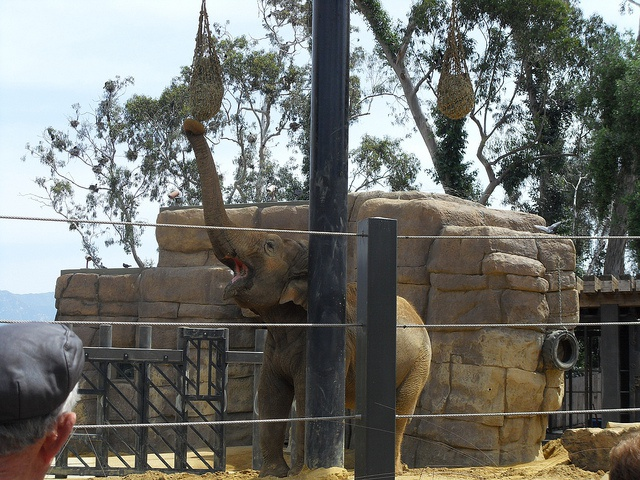Describe the objects in this image and their specific colors. I can see elephant in white, black, and gray tones, people in white, black, gray, darkgray, and maroon tones, and people in white, black, maroon, and gray tones in this image. 